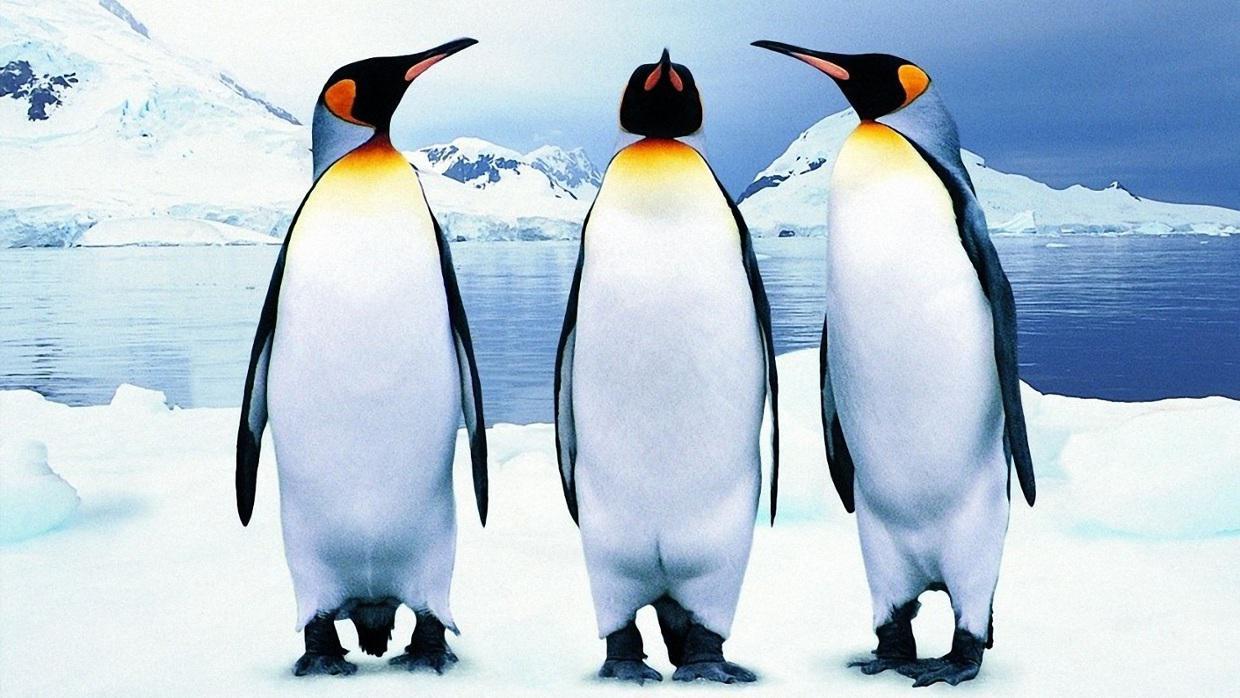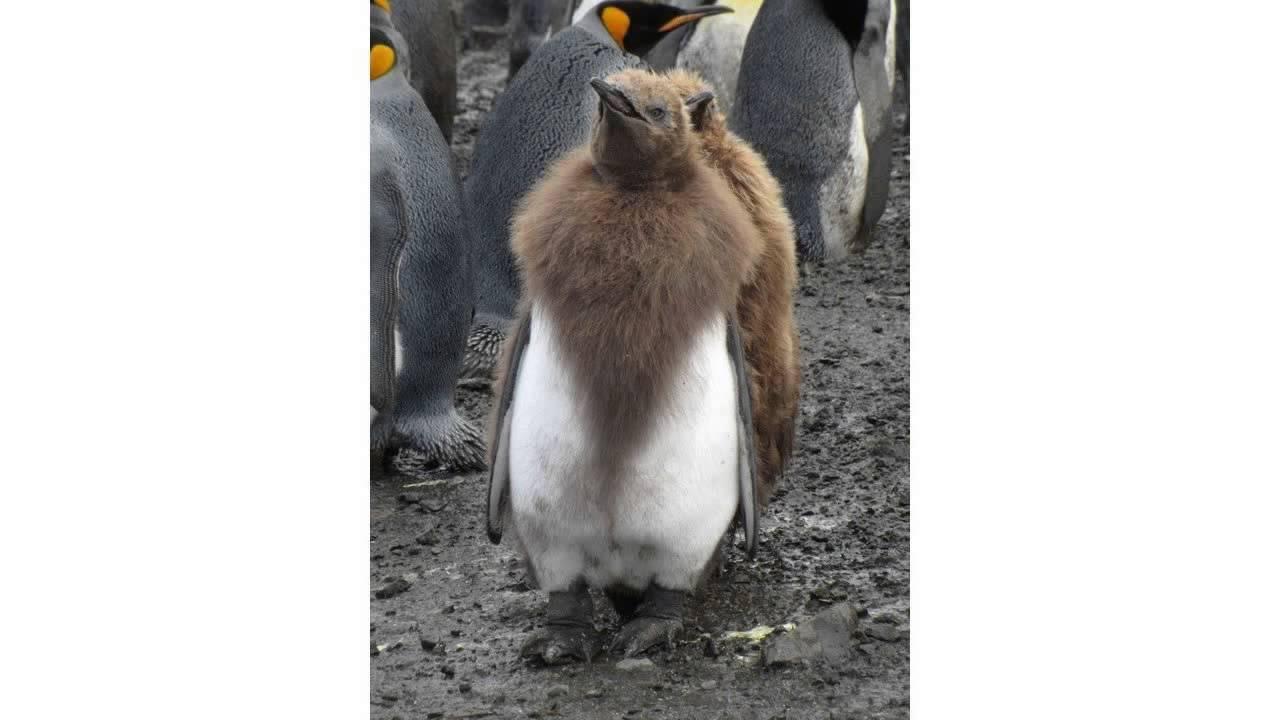The first image is the image on the left, the second image is the image on the right. Examine the images to the left and right. Is the description "There is less than four penguins in at least one of the images." accurate? Answer yes or no. Yes. The first image is the image on the left, the second image is the image on the right. For the images displayed, is the sentence "An image shows a flock of mostly brown-feathered penguins." factually correct? Answer yes or no. No. 